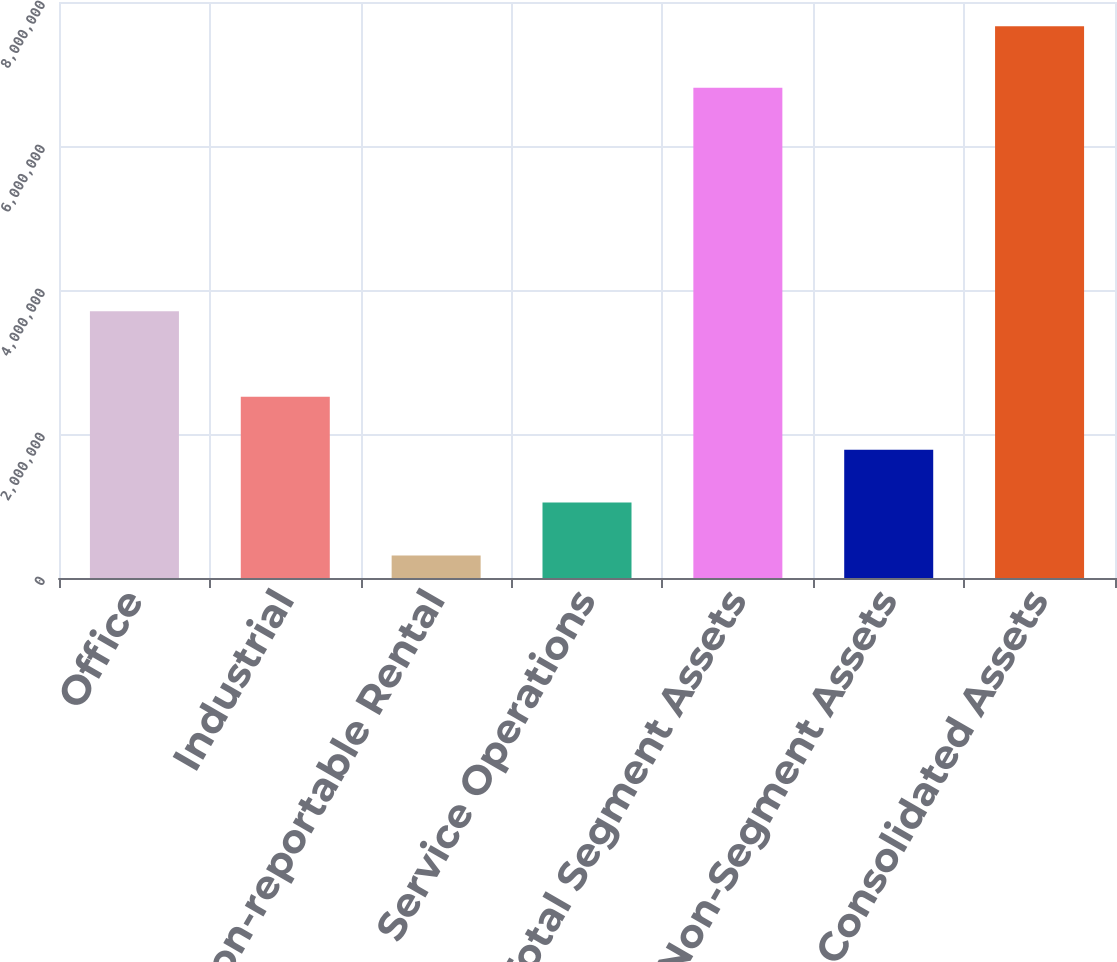Convert chart to OTSL. <chart><loc_0><loc_0><loc_500><loc_500><bar_chart><fcel>Office<fcel>Industrial<fcel>Non-reportable Rental<fcel>Service Operations<fcel>Total Segment Assets<fcel>Non-Segment Assets<fcel>Consolidated Assets<nl><fcel>3.70593e+06<fcel>2.51717e+06<fcel>312246<fcel>1.04722e+06<fcel>6.80771e+06<fcel>1.78219e+06<fcel>7.66198e+06<nl></chart> 